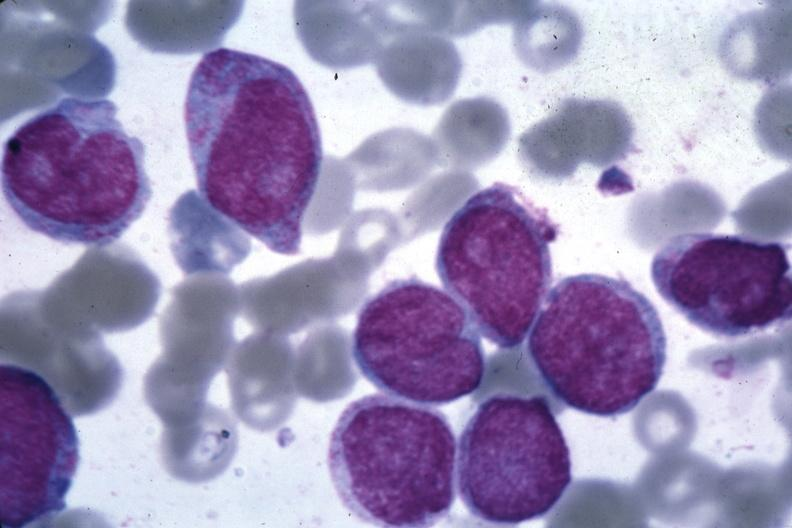s bone marrow present?
Answer the question using a single word or phrase. Yes 